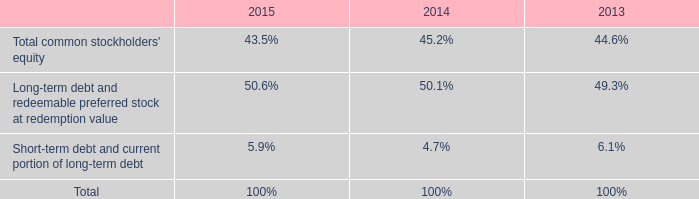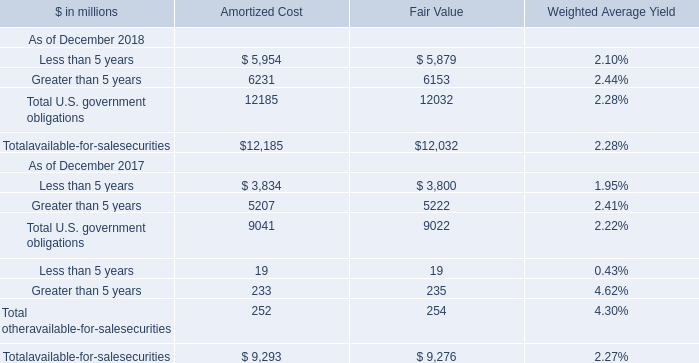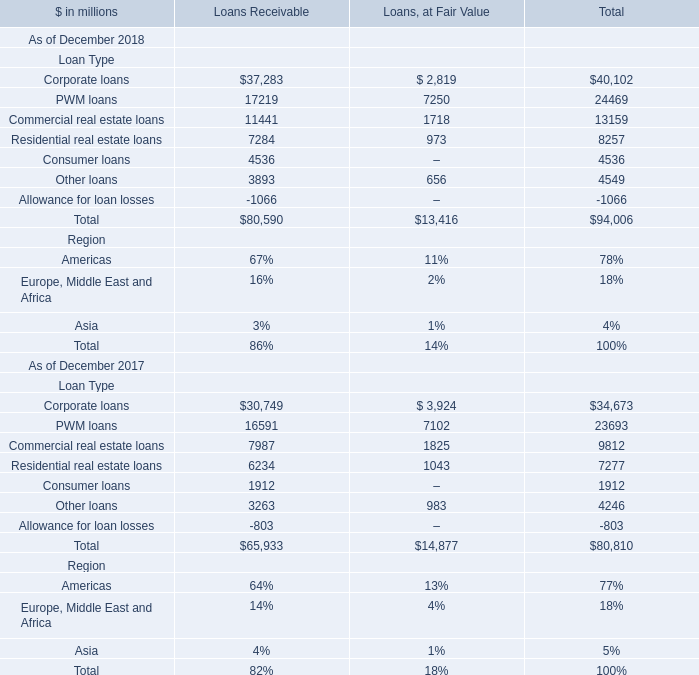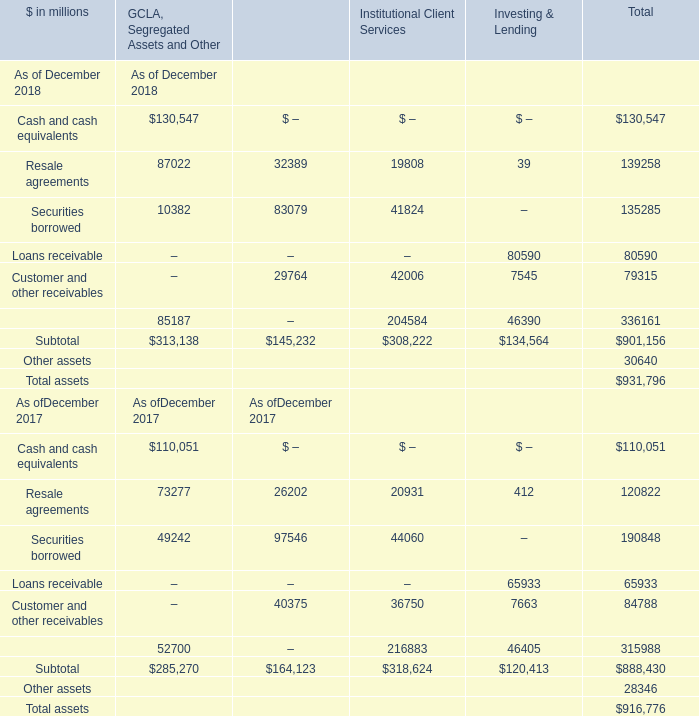How many elements show negative value in 2018 for Secured Client Financing? 
Answer: 0. 